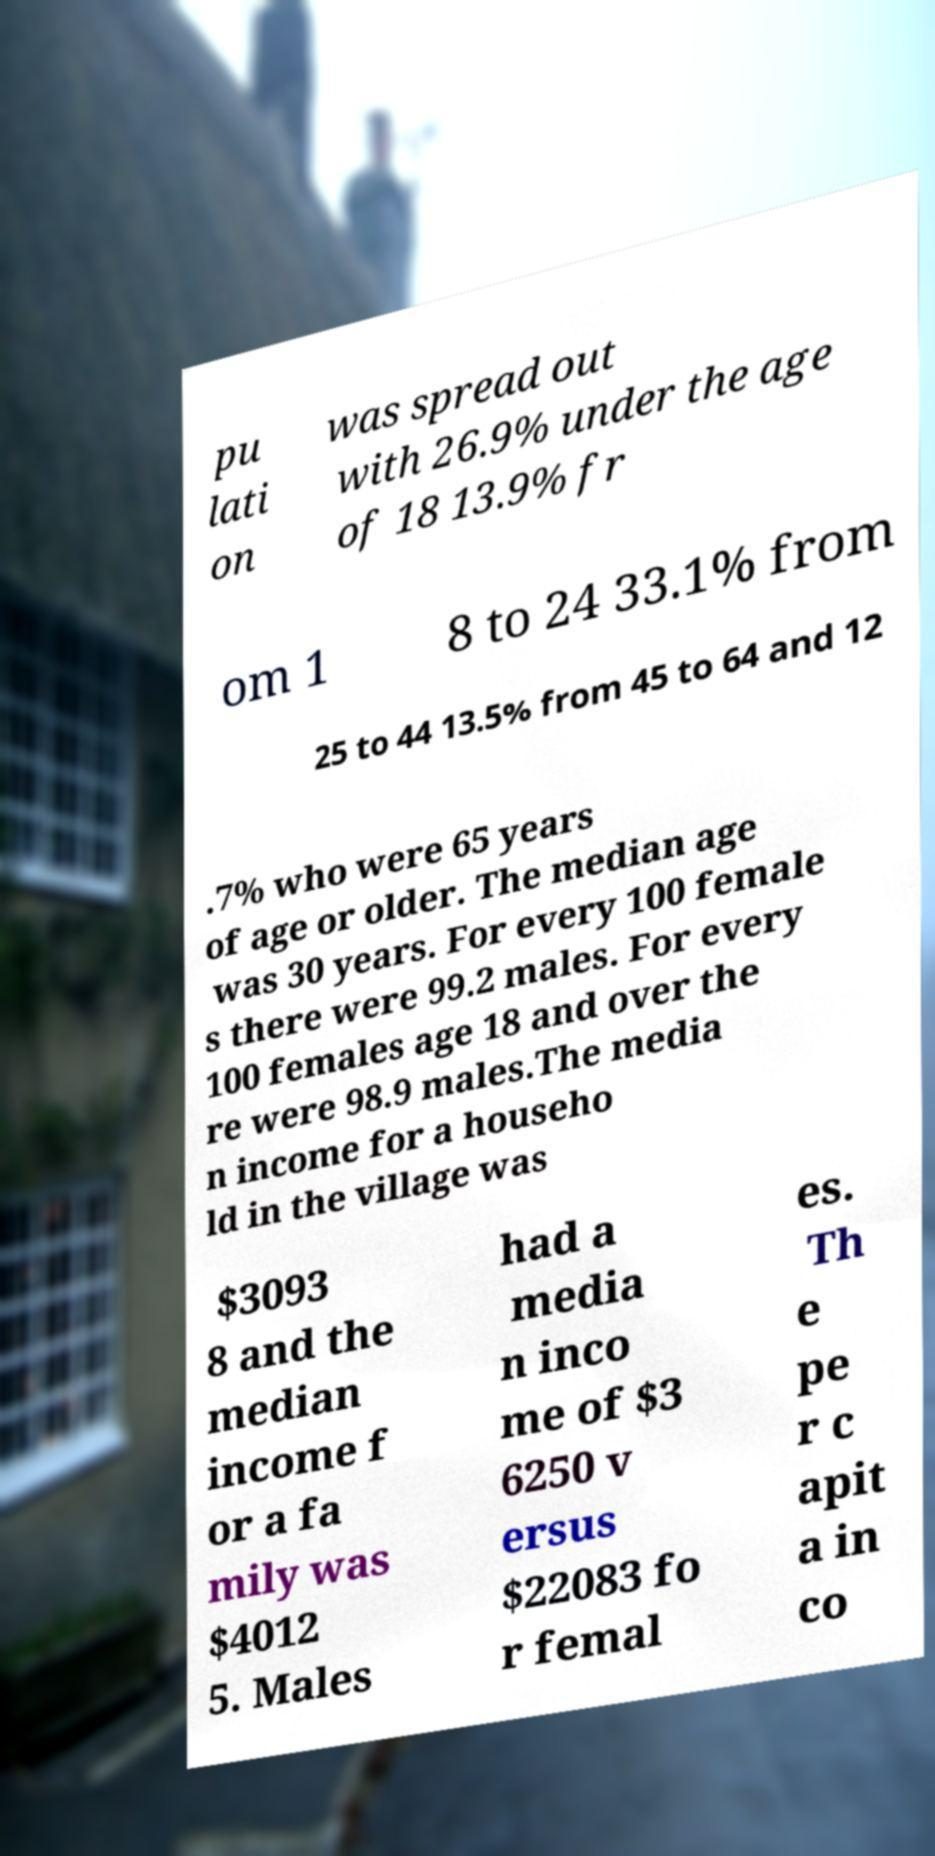I need the written content from this picture converted into text. Can you do that? pu lati on was spread out with 26.9% under the age of 18 13.9% fr om 1 8 to 24 33.1% from 25 to 44 13.5% from 45 to 64 and 12 .7% who were 65 years of age or older. The median age was 30 years. For every 100 female s there were 99.2 males. For every 100 females age 18 and over the re were 98.9 males.The media n income for a househo ld in the village was $3093 8 and the median income f or a fa mily was $4012 5. Males had a media n inco me of $3 6250 v ersus $22083 fo r femal es. Th e pe r c apit a in co 